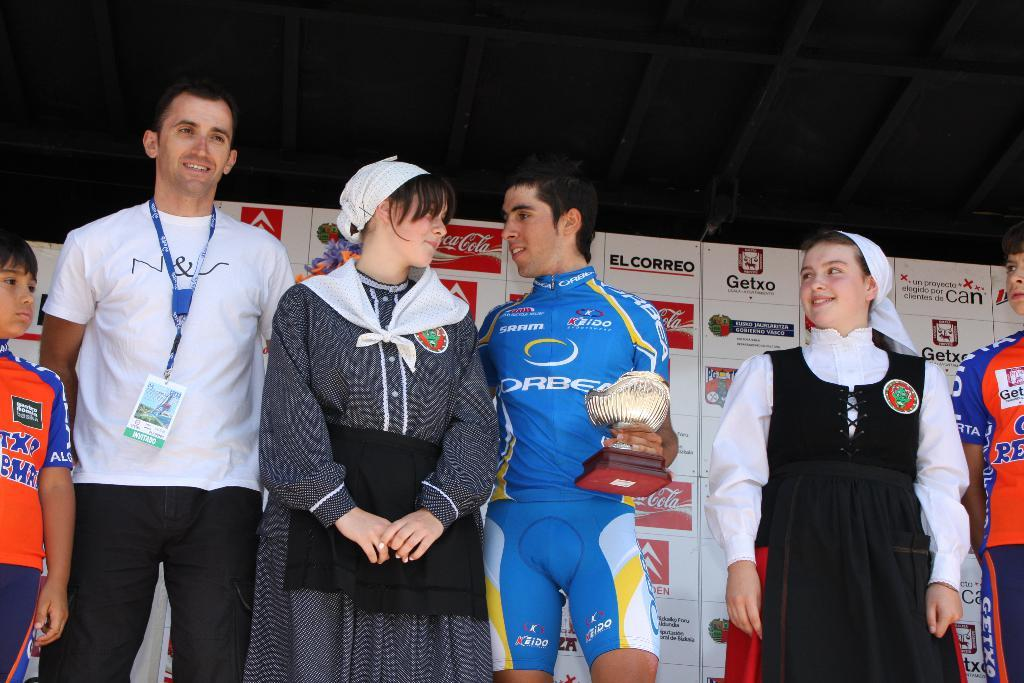<image>
Give a short and clear explanation of the subsequent image. El Correo is one of the advisement on the board behind the winner 